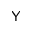<formula> <loc_0><loc_0><loc_500><loc_500>Y</formula> 